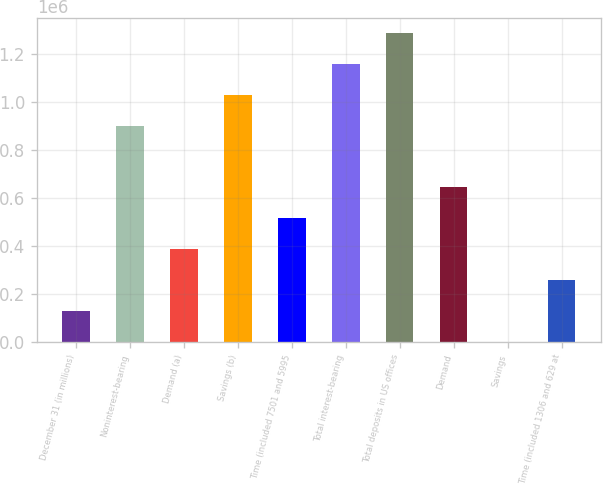Convert chart to OTSL. <chart><loc_0><loc_0><loc_500><loc_500><bar_chart><fcel>December 31 (in millions)<fcel>Noninterest-bearing<fcel>Demand (a)<fcel>Savings (b)<fcel>Time (included 7501 and 5995<fcel>Total interest-bearing<fcel>Total deposits in US offices<fcel>Demand<fcel>Savings<fcel>Time (included 1306 and 629 at<nl><fcel>129751<fcel>901760<fcel>387088<fcel>1.03043e+06<fcel>515756<fcel>1.1591e+06<fcel>1.28776e+06<fcel>644424<fcel>1083<fcel>258419<nl></chart> 